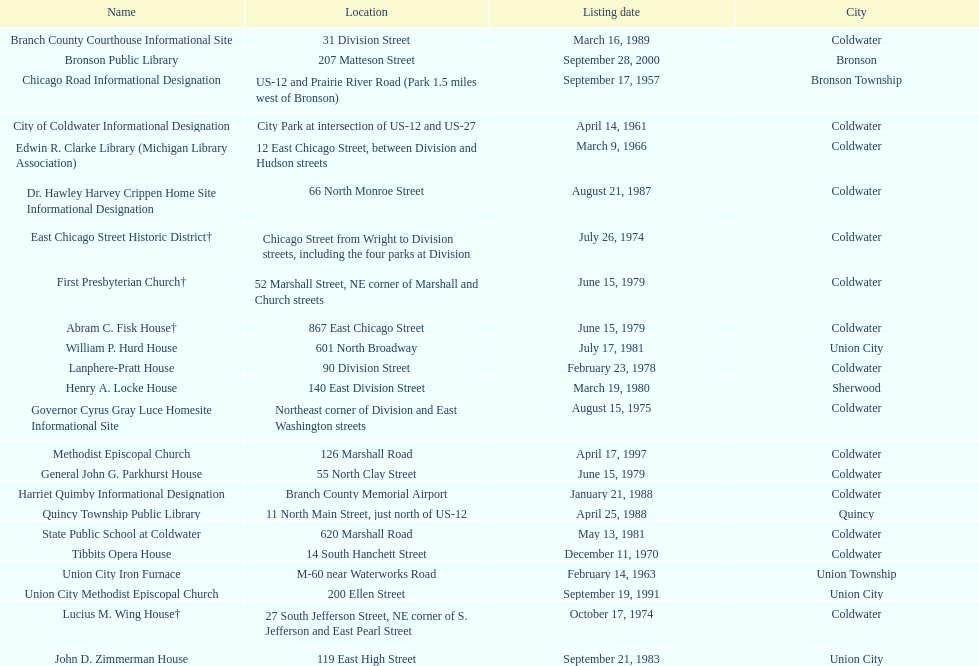Which city has the largest number of historic sites? Coldwater. 